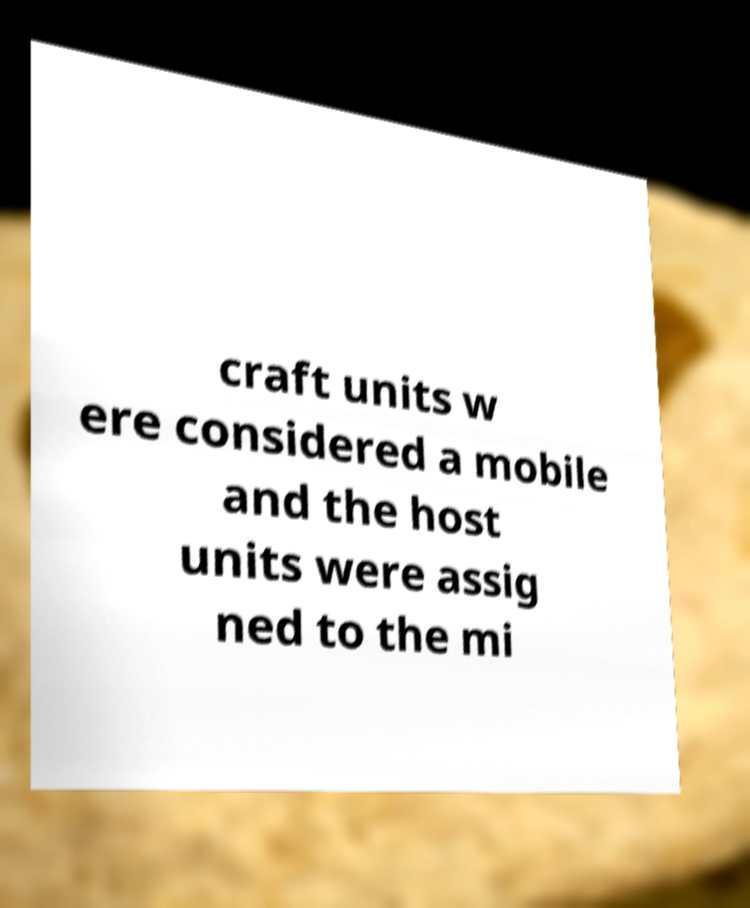What messages or text are displayed in this image? I need them in a readable, typed format. craft units w ere considered a mobile and the host units were assig ned to the mi 